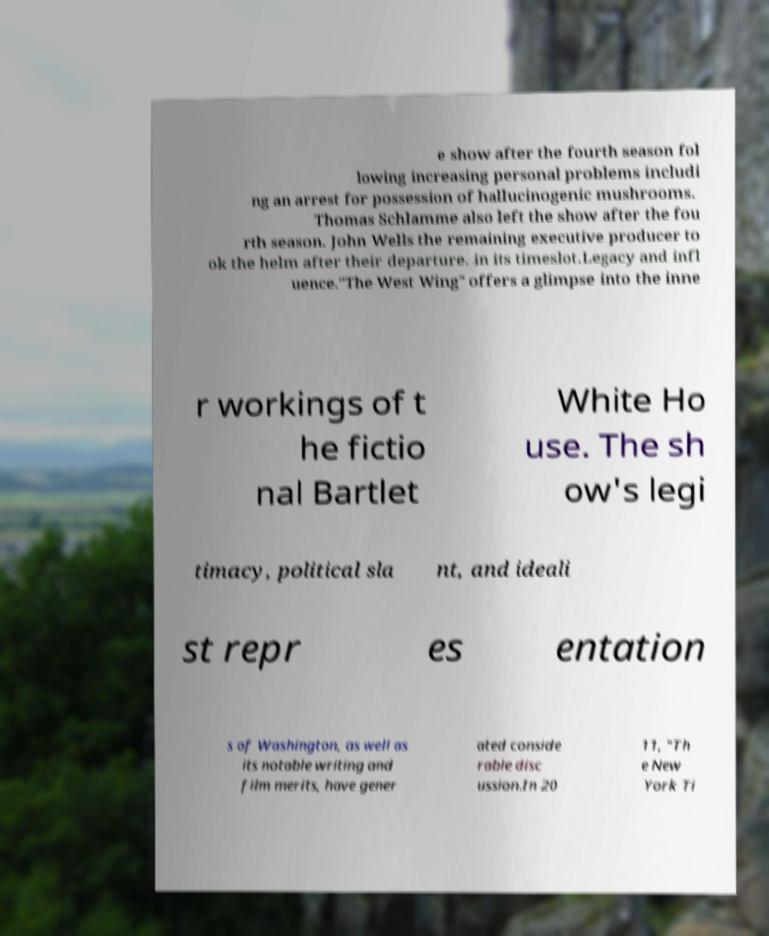Could you assist in decoding the text presented in this image and type it out clearly? e show after the fourth season fol lowing increasing personal problems includi ng an arrest for possession of hallucinogenic mushrooms. Thomas Schlamme also left the show after the fou rth season. John Wells the remaining executive producer to ok the helm after their departure. in its timeslot.Legacy and infl uence."The West Wing" offers a glimpse into the inne r workings of t he fictio nal Bartlet White Ho use. The sh ow's legi timacy, political sla nt, and ideali st repr es entation s of Washington, as well as its notable writing and film merits, have gener ated conside rable disc ussion.In 20 11, "Th e New York Ti 